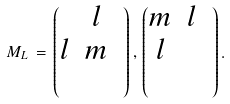<formula> <loc_0><loc_0><loc_500><loc_500>M _ { L } \, = \, \begin{pmatrix} & l & \\ l & m & \\ & & \end{pmatrix} , \, \begin{pmatrix} m & l & \\ l & & \\ & & \end{pmatrix} .</formula> 